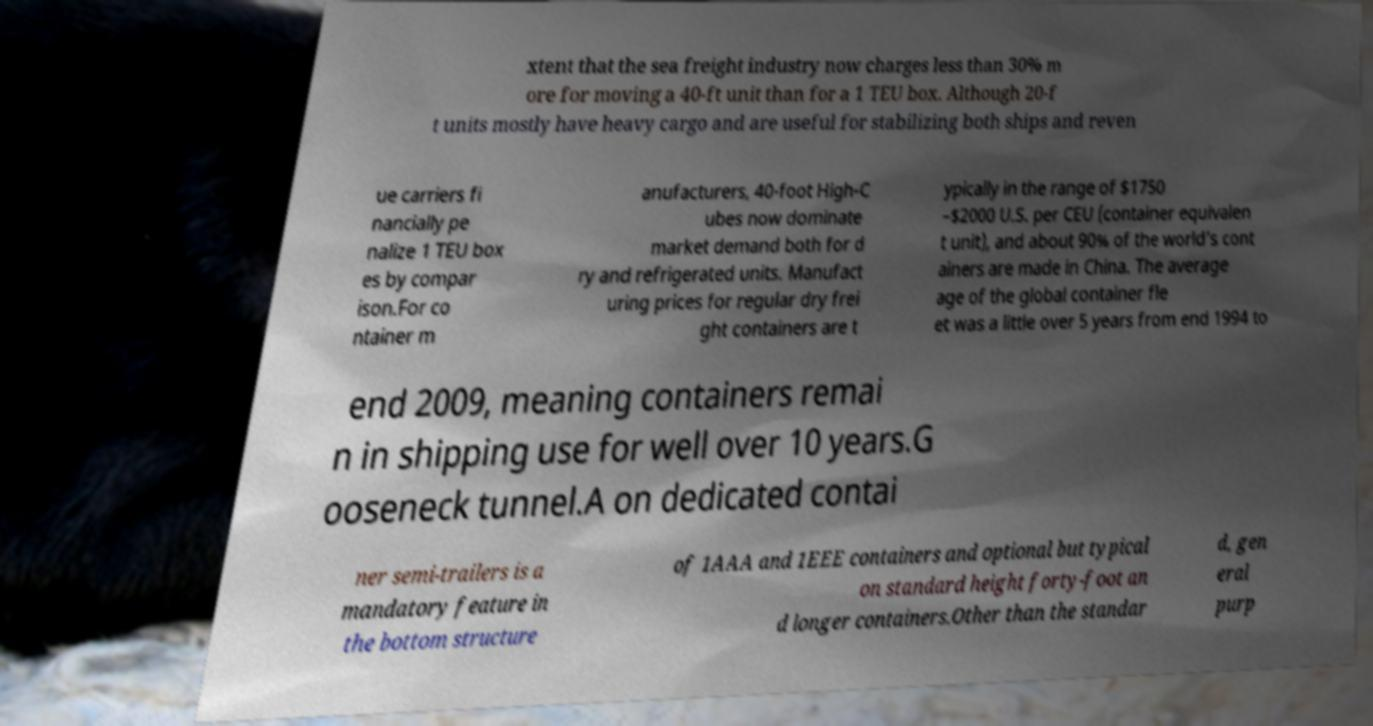Please identify and transcribe the text found in this image. xtent that the sea freight industry now charges less than 30% m ore for moving a 40-ft unit than for a 1 TEU box. Although 20-f t units mostly have heavy cargo and are useful for stabilizing both ships and reven ue carriers fi nancially pe nalize 1 TEU box es by compar ison.For co ntainer m anufacturers, 40-foot High-C ubes now dominate market demand both for d ry and refrigerated units. Manufact uring prices for regular dry frei ght containers are t ypically in the range of $1750 –$2000 U.S. per CEU (container equivalen t unit), and about 90% of the world's cont ainers are made in China. The average age of the global container fle et was a little over 5 years from end 1994 to end 2009, meaning containers remai n in shipping use for well over 10 years.G ooseneck tunnel.A on dedicated contai ner semi-trailers is a mandatory feature in the bottom structure of 1AAA and 1EEE containers and optional but typical on standard height forty-foot an d longer containers.Other than the standar d, gen eral purp 